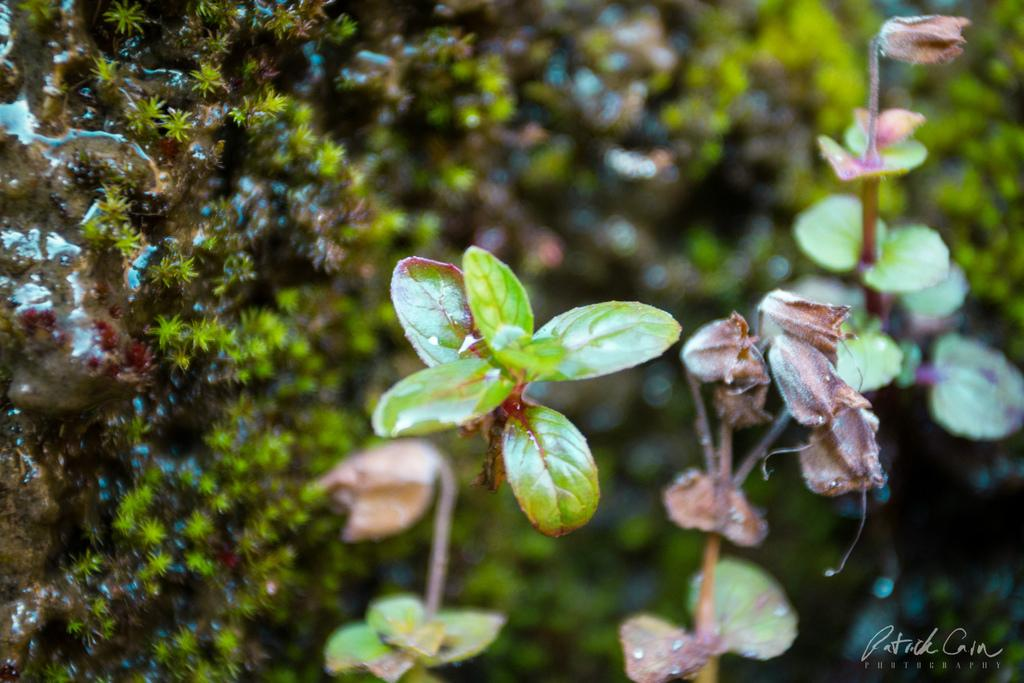What type of living organisms can be seen in the image? Plants can be seen in the image. What is on the rock in the image? There is moss on a rock in the image. Is there any text or marking in the image? Yes, there is a watermark in the bottom right corner of the image. What type of bomb is hidden in the image? There is no bomb present in the image. Can you see a badge on any of the plants in the image? There is no badge present on any of the plants in the image. 